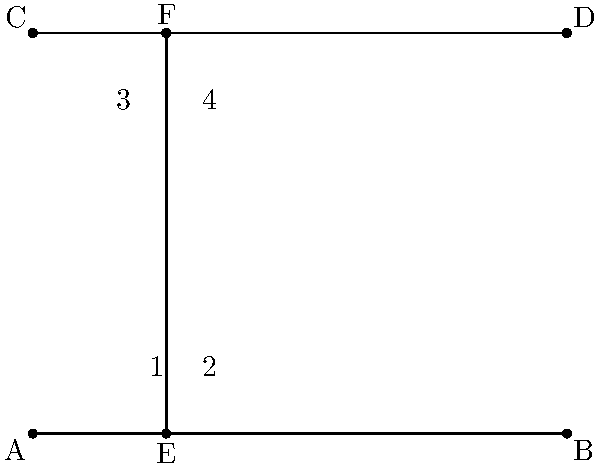In the context of designing an interactive geometry game for learning, identify the alternate interior angles in the given figure where line EF is a transversal crossing parallel lines AB and CD. How might recognizing these angles enhance a student's understanding of geometric relationships? To identify the alternate interior angles and understand their importance in geometric relationships, let's follow these steps:

1) First, recall the definition of alternate interior angles:
   - They are formed when a transversal crosses two parallel lines.
   - They are on opposite sides of the transversal.
   - They are inside the parallel lines.

2) In this figure:
   - AB and CD are parallel lines.
   - EF is the transversal.

3) Identifying the alternate interior angles:
   - Angle 2 and angle 3 form one pair of alternate interior angles.
   - Angle 1 and angle 4 form another pair of alternate interior angles.

4) Why this is important for understanding geometric relationships:
   - Alternate interior angles are always congruent when the lines are parallel.
   - This property is crucial for proving other geometric theorems, such as the sum of angles in a triangle.
   - Understanding this concept helps in solving more complex geometric problems.

5) In an interactive game context:
   - Students could drag and rotate the transversal to see how the angles change.
   - They could measure the angles to verify their congruence.
   - This hands-on approach reinforces the concept more effectively than static diagrams.

6) Educational psychology perspective:
   - Interactive exploration promotes active learning.
   - Visualizing the relationships between angles enhances spatial reasoning skills.
   - The immediate feedback in a game environment can reinforce correct understanding and quickly correct misconceptions.
Answer: Angles 2 and 3, and angles 1 and 4 are alternate interior angles. Recognizing these enhances understanding of parallel line properties and supports development of spatial reasoning skills through interactive exploration. 